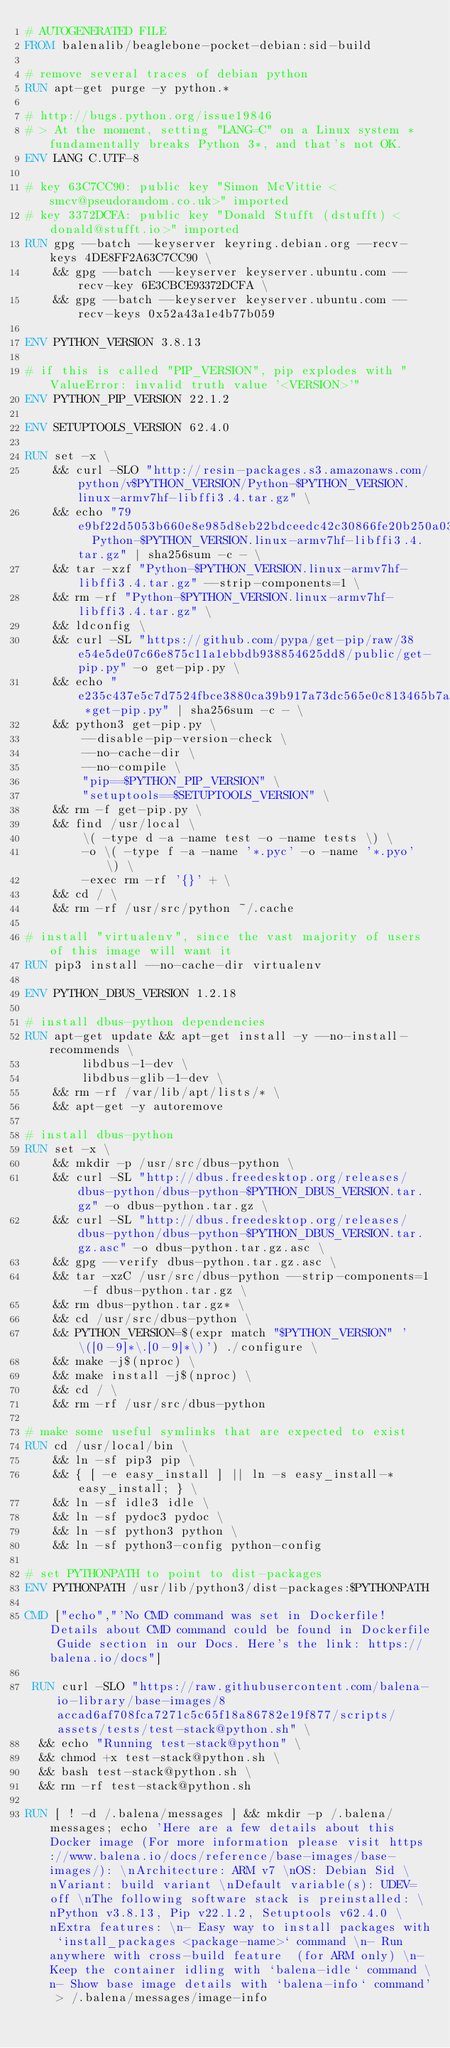<code> <loc_0><loc_0><loc_500><loc_500><_Dockerfile_># AUTOGENERATED FILE
FROM balenalib/beaglebone-pocket-debian:sid-build

# remove several traces of debian python
RUN apt-get purge -y python.*

# http://bugs.python.org/issue19846
# > At the moment, setting "LANG=C" on a Linux system *fundamentally breaks Python 3*, and that's not OK.
ENV LANG C.UTF-8

# key 63C7CC90: public key "Simon McVittie <smcv@pseudorandom.co.uk>" imported
# key 3372DCFA: public key "Donald Stufft (dstufft) <donald@stufft.io>" imported
RUN gpg --batch --keyserver keyring.debian.org --recv-keys 4DE8FF2A63C7CC90 \
    && gpg --batch --keyserver keyserver.ubuntu.com --recv-key 6E3CBCE93372DCFA \
    && gpg --batch --keyserver keyserver.ubuntu.com --recv-keys 0x52a43a1e4b77b059

ENV PYTHON_VERSION 3.8.13

# if this is called "PIP_VERSION", pip explodes with "ValueError: invalid truth value '<VERSION>'"
ENV PYTHON_PIP_VERSION 22.1.2

ENV SETUPTOOLS_VERSION 62.4.0

RUN set -x \
    && curl -SLO "http://resin-packages.s3.amazonaws.com/python/v$PYTHON_VERSION/Python-$PYTHON_VERSION.linux-armv7hf-libffi3.4.tar.gz" \
    && echo "79e9bf22d5053b660e8e985d8eb22bdceedc42c30866fe20b250a03cf1695208  Python-$PYTHON_VERSION.linux-armv7hf-libffi3.4.tar.gz" | sha256sum -c - \
    && tar -xzf "Python-$PYTHON_VERSION.linux-armv7hf-libffi3.4.tar.gz" --strip-components=1 \
    && rm -rf "Python-$PYTHON_VERSION.linux-armv7hf-libffi3.4.tar.gz" \
    && ldconfig \
    && curl -SL "https://github.com/pypa/get-pip/raw/38e54e5de07c66e875c11a1ebbdb938854625dd8/public/get-pip.py" -o get-pip.py \
    && echo "e235c437e5c7d7524fbce3880ca39b917a73dc565e0c813465b7a7a329bb279a *get-pip.py" | sha256sum -c - \
    && python3 get-pip.py \
        --disable-pip-version-check \
        --no-cache-dir \
        --no-compile \
        "pip==$PYTHON_PIP_VERSION" \
        "setuptools==$SETUPTOOLS_VERSION" \
    && rm -f get-pip.py \
    && find /usr/local \
        \( -type d -a -name test -o -name tests \) \
        -o \( -type f -a -name '*.pyc' -o -name '*.pyo' \) \
        -exec rm -rf '{}' + \
    && cd / \
    && rm -rf /usr/src/python ~/.cache

# install "virtualenv", since the vast majority of users of this image will want it
RUN pip3 install --no-cache-dir virtualenv

ENV PYTHON_DBUS_VERSION 1.2.18

# install dbus-python dependencies 
RUN apt-get update && apt-get install -y --no-install-recommends \
		libdbus-1-dev \
		libdbus-glib-1-dev \
	&& rm -rf /var/lib/apt/lists/* \
	&& apt-get -y autoremove

# install dbus-python
RUN set -x \
	&& mkdir -p /usr/src/dbus-python \
	&& curl -SL "http://dbus.freedesktop.org/releases/dbus-python/dbus-python-$PYTHON_DBUS_VERSION.tar.gz" -o dbus-python.tar.gz \
	&& curl -SL "http://dbus.freedesktop.org/releases/dbus-python/dbus-python-$PYTHON_DBUS_VERSION.tar.gz.asc" -o dbus-python.tar.gz.asc \
	&& gpg --verify dbus-python.tar.gz.asc \
	&& tar -xzC /usr/src/dbus-python --strip-components=1 -f dbus-python.tar.gz \
	&& rm dbus-python.tar.gz* \
	&& cd /usr/src/dbus-python \
	&& PYTHON_VERSION=$(expr match "$PYTHON_VERSION" '\([0-9]*\.[0-9]*\)') ./configure \
	&& make -j$(nproc) \
	&& make install -j$(nproc) \
	&& cd / \
	&& rm -rf /usr/src/dbus-python

# make some useful symlinks that are expected to exist
RUN cd /usr/local/bin \
	&& ln -sf pip3 pip \
	&& { [ -e easy_install ] || ln -s easy_install-* easy_install; } \
	&& ln -sf idle3 idle \
	&& ln -sf pydoc3 pydoc \
	&& ln -sf python3 python \
	&& ln -sf python3-config python-config

# set PYTHONPATH to point to dist-packages
ENV PYTHONPATH /usr/lib/python3/dist-packages:$PYTHONPATH

CMD ["echo","'No CMD command was set in Dockerfile! Details about CMD command could be found in Dockerfile Guide section in our Docs. Here's the link: https://balena.io/docs"]

 RUN curl -SLO "https://raw.githubusercontent.com/balena-io-library/base-images/8accad6af708fca7271c5c65f18a86782e19f877/scripts/assets/tests/test-stack@python.sh" \
  && echo "Running test-stack@python" \
  && chmod +x test-stack@python.sh \
  && bash test-stack@python.sh \
  && rm -rf test-stack@python.sh 

RUN [ ! -d /.balena/messages ] && mkdir -p /.balena/messages; echo 'Here are a few details about this Docker image (For more information please visit https://www.balena.io/docs/reference/base-images/base-images/): \nArchitecture: ARM v7 \nOS: Debian Sid \nVariant: build variant \nDefault variable(s): UDEV=off \nThe following software stack is preinstalled: \nPython v3.8.13, Pip v22.1.2, Setuptools v62.4.0 \nExtra features: \n- Easy way to install packages with `install_packages <package-name>` command \n- Run anywhere with cross-build feature  (for ARM only) \n- Keep the container idling with `balena-idle` command \n- Show base image details with `balena-info` command' > /.balena/messages/image-info</code> 